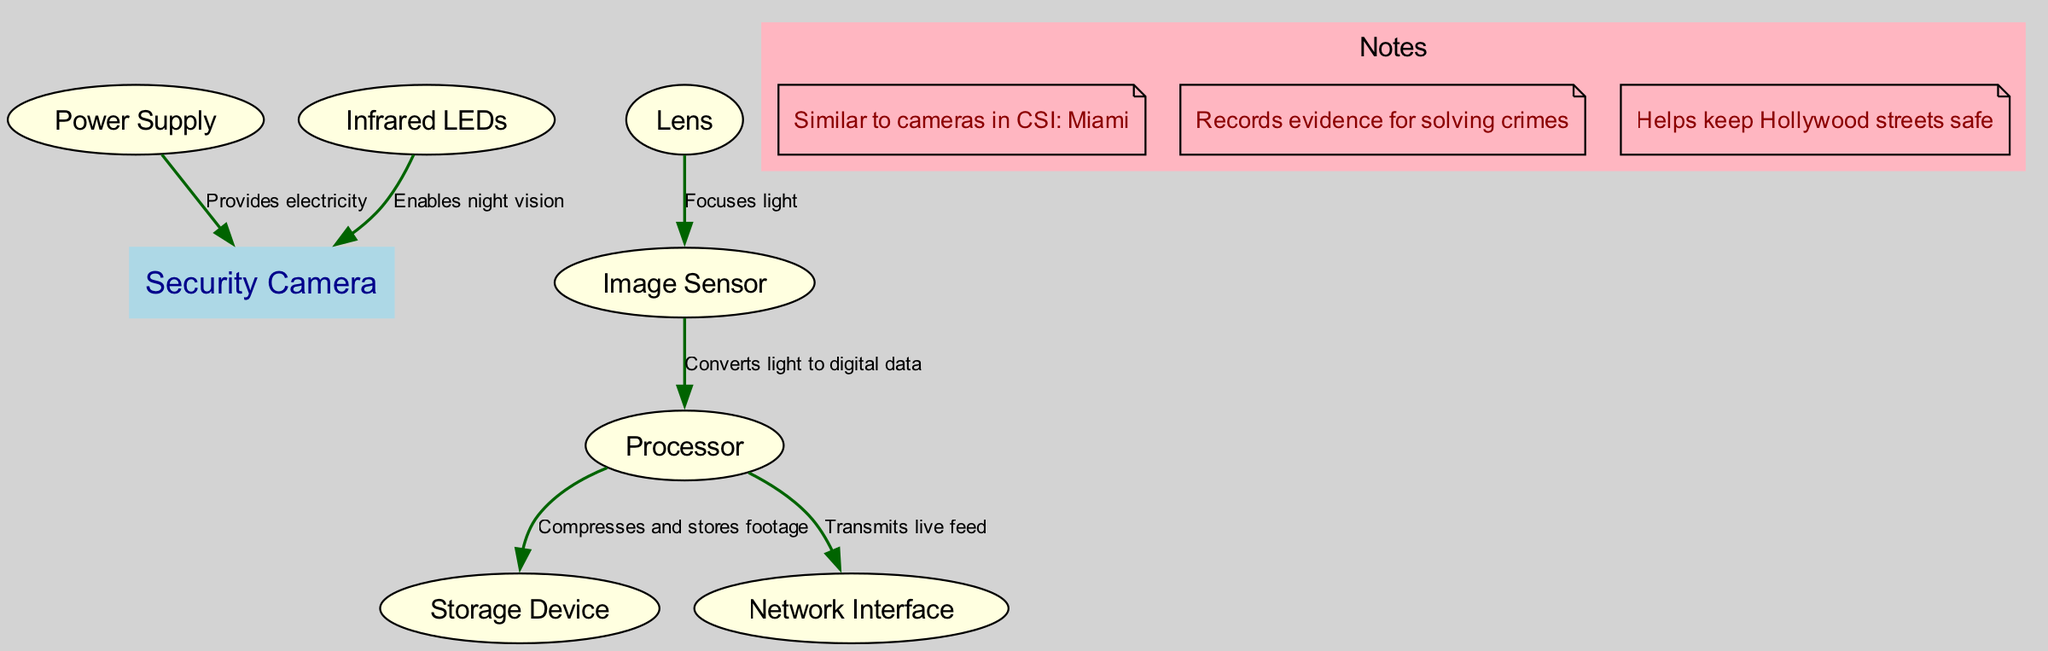What is the central node of the diagram? The central node is explicitly labeled in the diagram as "Security Camera."
Answer: Security Camera How many components are there in total? The diagram lists seven components, which can be counted individually as follows: Lens, Image Sensor, Processor, Storage Device, Network Interface, Power Supply, Infrared LEDs.
Answer: 7 What does the lens do? The diagram indicates that the lens "Focuses light" to the image sensor, which means its function is clearly defined.
Answer: Focuses light Which component does the processor send data to for storage? The diagram shows a direct connection labeled "Compresses and stores footage" from the processor to the storage device, indicating this is where data is sent.
Answer: Storage Device How does the camera provide night vision capability? According to the diagram, the infrared LEDs "Enables night vision," which directly highlights how this component contributes to the camera's functionality.
Answer: Infrared LEDs What role does the power supply play in relation to the security camera? The diagram states that the power supply "Provides electricity" to the security camera, indicating this is its primary role.
Answer: Provides electricity What component converts light into digital data? The image sensor is directly linked to the lens in the diagram, receiving focused light and converting it into digital data, as labeled in the connection.
Answer: Image Sensor How many notes are included in the diagram? The diagram connects to a subgraph labeled 'Notes,' which contains three distinct points, thereby giving a clear count.
Answer: 3 What is the function of the network interface in the security camera system? The diagram shows that the network interface is connected to the processor with the label "Transmits live feed," directly describing its function.
Answer: Transmits live feed 